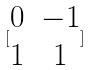Convert formula to latex. <formula><loc_0><loc_0><loc_500><loc_500>[ \begin{matrix} 0 & - 1 \\ 1 & 1 \end{matrix} ]</formula> 